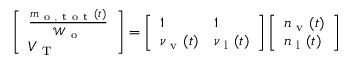<formula> <loc_0><loc_0><loc_500><loc_500>\begin{array} { r } { \left [ \begin{array} { l } { \frac { m _ { o , t o t } ( t ) } { \mathcal { W } _ { o } } } \\ { V _ { T } } \end{array} \right ] = \left [ \begin{array} { l l } { 1 } & { 1 } \\ { \nu _ { v } ( t ) } & { \nu _ { l } ( t ) } \end{array} \right ] \left [ \begin{array} { l } { n _ { v } ( t ) } \\ { n _ { l } ( t ) } \end{array} \right ] } \end{array}</formula> 